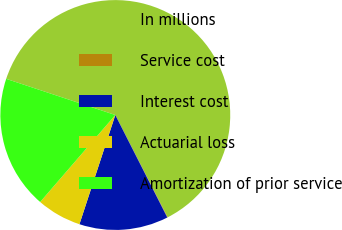<chart> <loc_0><loc_0><loc_500><loc_500><pie_chart><fcel>In millions<fcel>Service cost<fcel>Interest cost<fcel>Actuarial loss<fcel>Amortization of prior service<nl><fcel>62.37%<fcel>0.06%<fcel>12.52%<fcel>6.29%<fcel>18.75%<nl></chart> 